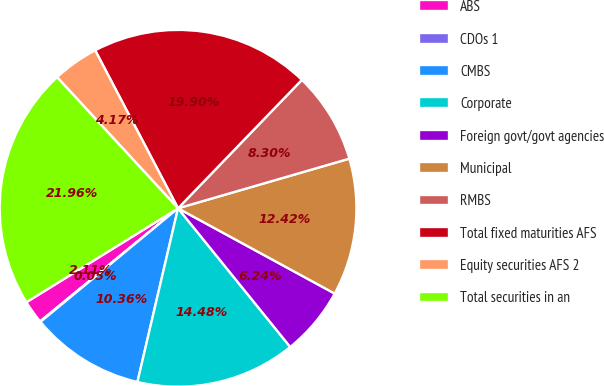Convert chart. <chart><loc_0><loc_0><loc_500><loc_500><pie_chart><fcel>ABS<fcel>CDOs 1<fcel>CMBS<fcel>Corporate<fcel>Foreign govt/govt agencies<fcel>Municipal<fcel>RMBS<fcel>Total fixed maturities AFS<fcel>Equity securities AFS 2<fcel>Total securities in an<nl><fcel>2.11%<fcel>0.05%<fcel>10.36%<fcel>14.48%<fcel>6.24%<fcel>12.42%<fcel>8.3%<fcel>19.9%<fcel>4.17%<fcel>21.96%<nl></chart> 